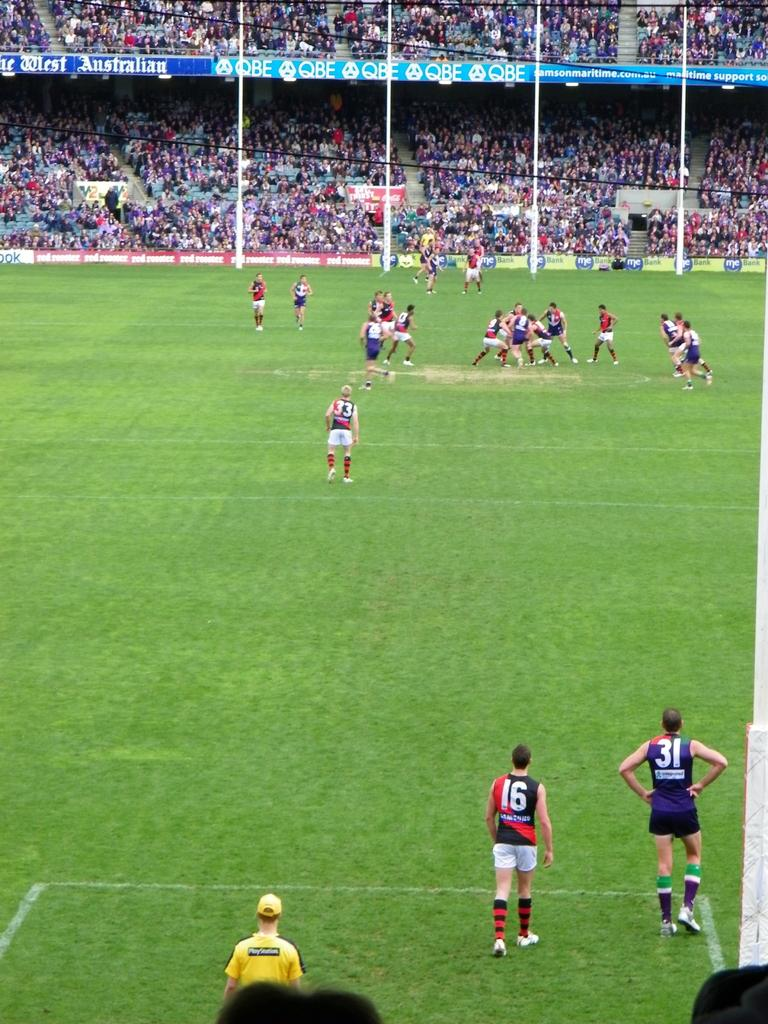Who or what can be seen in the image? There are people in the image. What type of natural environment is visible in the image? There is grass visible in the image. What structures can be seen in the background of the image? There are poles, a stadium, hoardings, and wires in the background of the image. What type of gathering or event might be taking place in the image? There is an audience in the background of the image, which suggests a gathering or event is happening. What month is it in the image? The month cannot be determined from the image, as there is no information about the date or time of year. Can you see any mice in the image? There are no mice present in the image. 